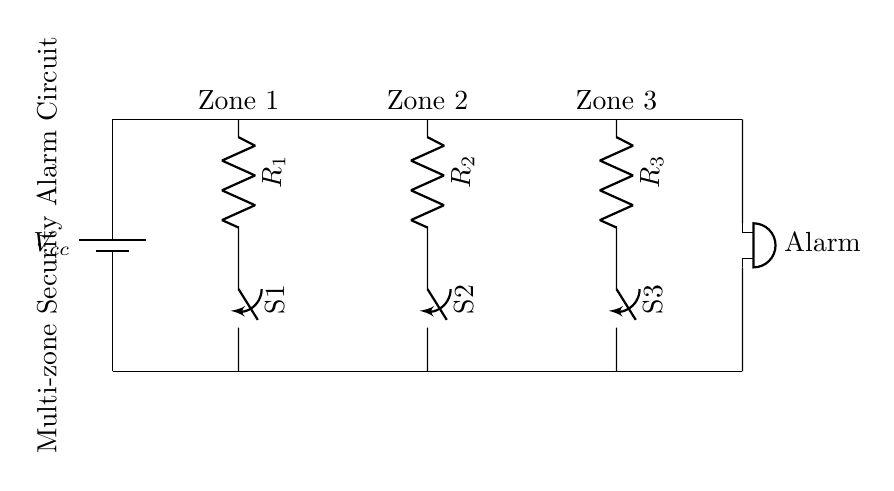What type of circuit is illustrated? The circuit illustrated is a parallel circuit because multiple paths for current exist, and components are connected alongside each other to the same voltage source.
Answer: Parallel How many zones are monitored by the alarm circuit? The alarm circuit monitors three zones, as indicated by the three labeled branches in the circuit diagram each designated as Zone 1, Zone 2, and Zone 3.
Answer: Three What is the role of the switches in this diagram? The switches control the connection of each zone to the alarm circuit, allowing for individual disarming of each zone when opened.
Answer: Control connection What happens if all the switches are closed? If all switches are closed, the current can flow through all three zones, activating the alarm if any of the zones detect an intrusion or trigger.
Answer: Alarm activates Which component is responsible for sound in the circuit? The buzzer is the component responsible for producing sound as an alarm indicator when any of the zones detect unauthorized access.
Answer: Buzzer What is the purpose of the resistors in each zone? The resistors limit the current flow in each zone, protecting the circuit components from overload and ensuring proper functioning of the alarm system.
Answer: Limit current What would happen if one resistor fails? If one resistor fails, it would affect only that specific zone, allowing the other zones to function normally while potentially causing an alarm condition if the failed zone detects an event.
Answer: Isolated zone failure 